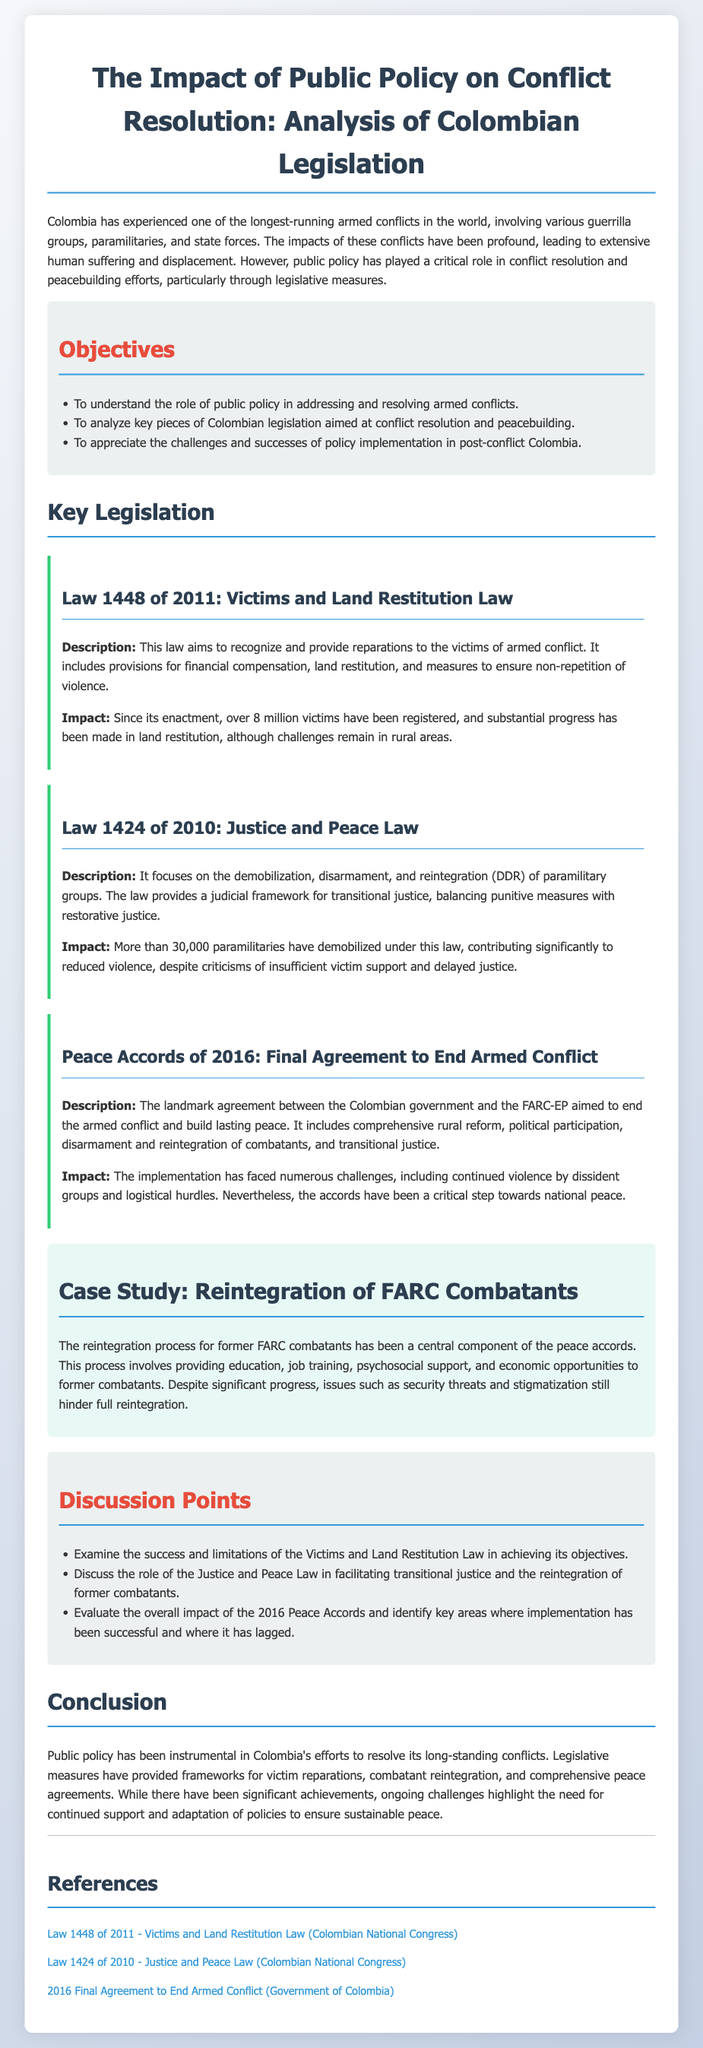What is the title of the lesson plan? The title of the lesson plan is stated at the beginning of the document.
Answer: The Impact of Public Policy on Conflict Resolution: Analysis of Colombian Legislation What year was Law 1448 enacted? The document provides the specific year associated with Law 1448 under key legislation.
Answer: 2011 How many victims have been registered under Law 1448? The document mentions a specific number of victims registered under Law 1448.
Answer: Over 8 million What is the main focus of the Justice and Peace Law? The document describes the primary focus of Law 1424.
Answer: Demobilization, disarmament, and reintegration of paramilitary groups What year were the Peace Accords signed? The document provides the year related to the Peace Accords.
Answer: 2016 What is one major challenge faced in the implementation of the Peace Accords? The document lists challenges faced in implementing the Peace Accords.
Answer: Continued violence by dissident groups What are two key components of the reintegration process for former FARC combatants? The document mentions several components in the reintegration process case study.
Answer: Education and job training What is one objective of the lesson plan? The document outlines several objectives listed under the objectives section.
Answer: To understand the role of public policy in addressing and resolving armed conflicts What color is used for the legislation section? The document describes the visual design used for this section.
Answer: Green (noted by the border-left color) 